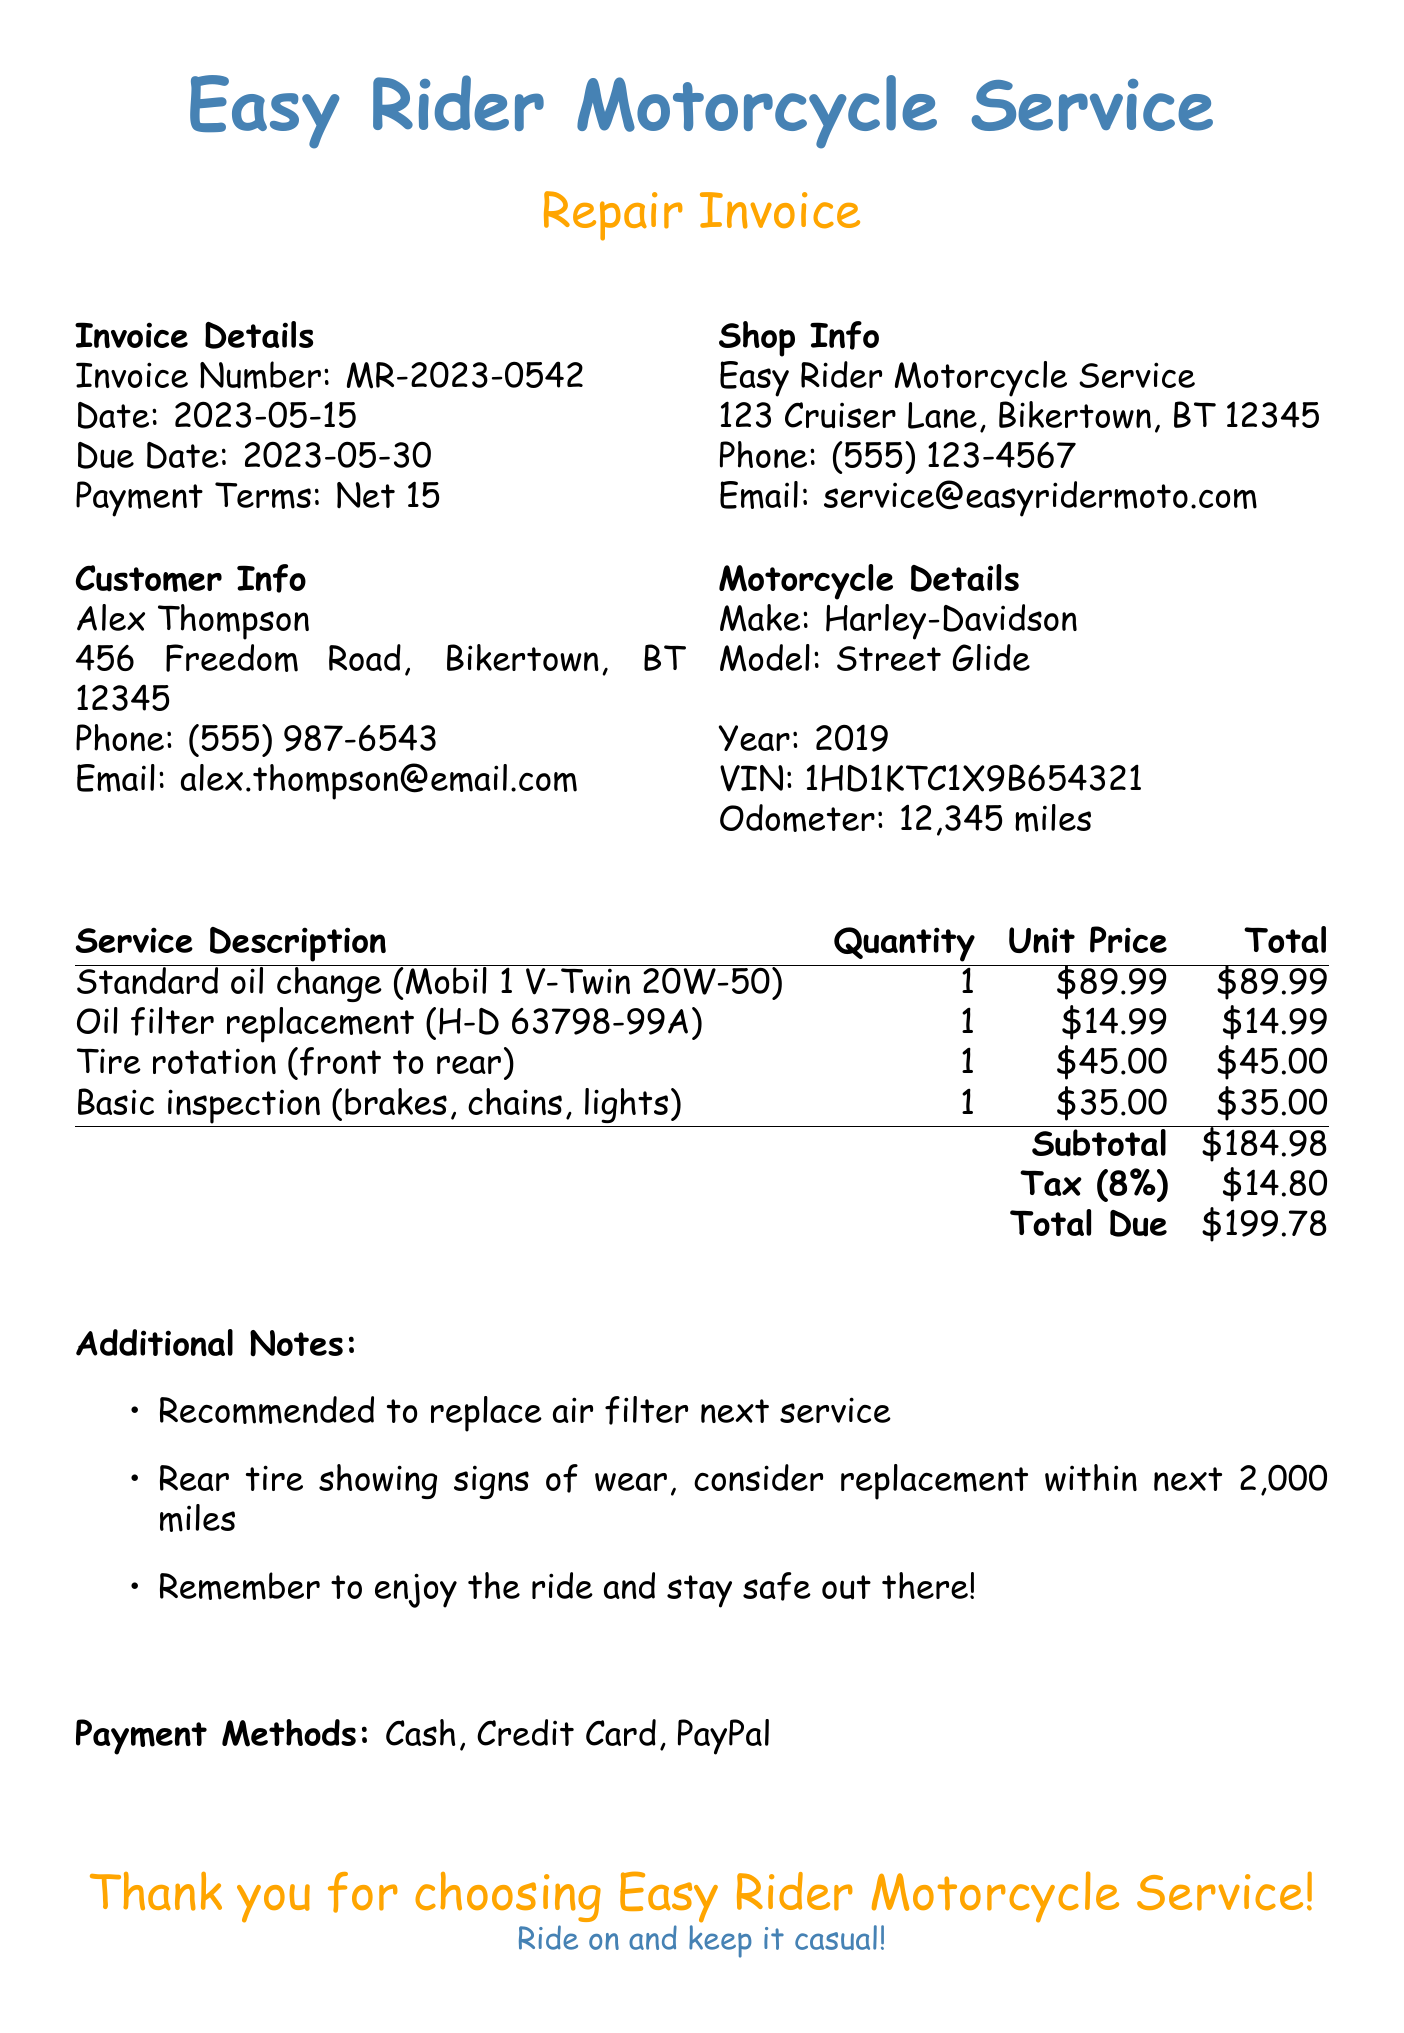What is the invoice number? The invoice number is specifically mentioned in the details section of the document.
Answer: MR-2023-0542 What is the due date for payment? The due date can be found in the invoice details section of the document.
Answer: 2023-05-30 Who is the customer? The customer information section provides the name of the individual receiving the services.
Answer: Alex Thompson What service involved tire rotation? Referring to the services listed, this describes a specific maintenance activity for the motorcycle.
Answer: Tire rotation (front to rear) What is the total due amount? The total due is calculated from the subtotal and tax amount in the totals section of the document.
Answer: $199.78 What is the tax rate applied? The tax rate is specifically noted in the totals section of the document.
Answer: 8% What does the additional note suggest about the rear tire? This note provides a reminder regarding the condition of a part of the motorcycle, indicating future action.
Answer: consider replacement within next 2,000 miles What method of payment is accepted? The payment methods listed inform about the options available for settling the invoice.
Answer: Cash, Credit Card, PayPal 